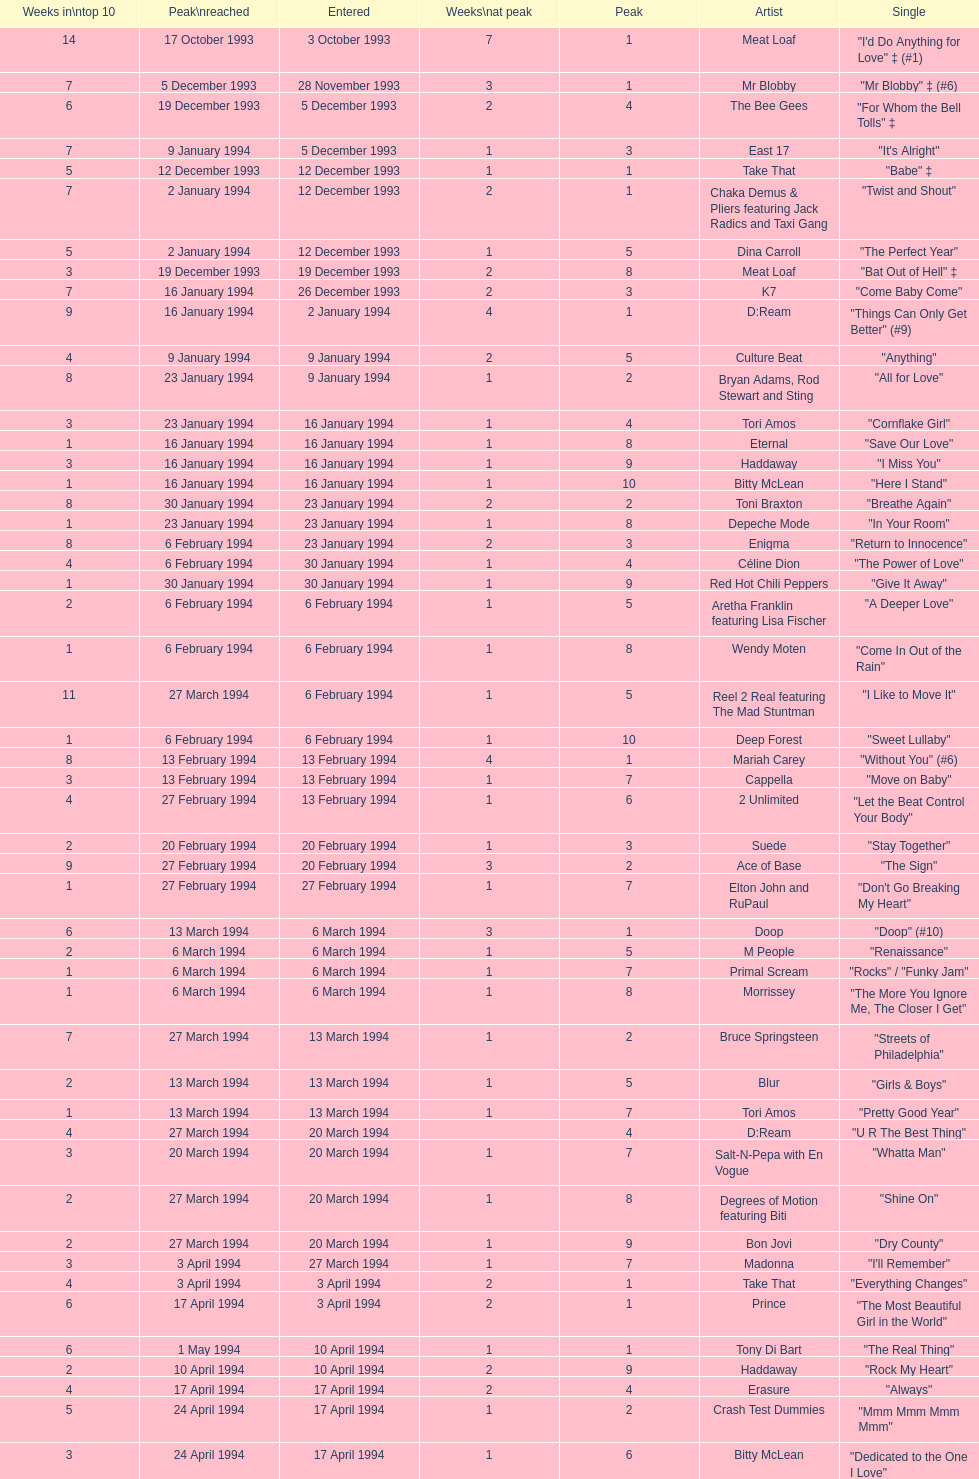Which artist only has its single entered on 2 january 1994? D:Ream. 